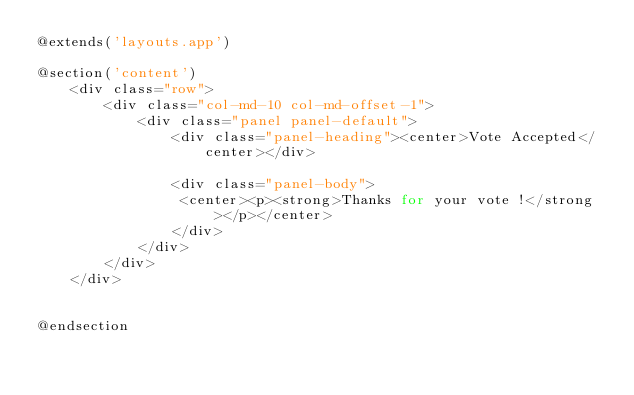<code> <loc_0><loc_0><loc_500><loc_500><_PHP_>@extends('layouts.app')

@section('content')
    <div class="row">
        <div class="col-md-10 col-md-offset-1">
            <div class="panel panel-default">
                <div class="panel-heading"><center>Vote Accepted</center></div>

                <div class="panel-body">
                 <center><p><strong>Thanks for your vote !</strong></p></center>
                </div>
            </div>
        </div>
    </div>


@endsection</code> 